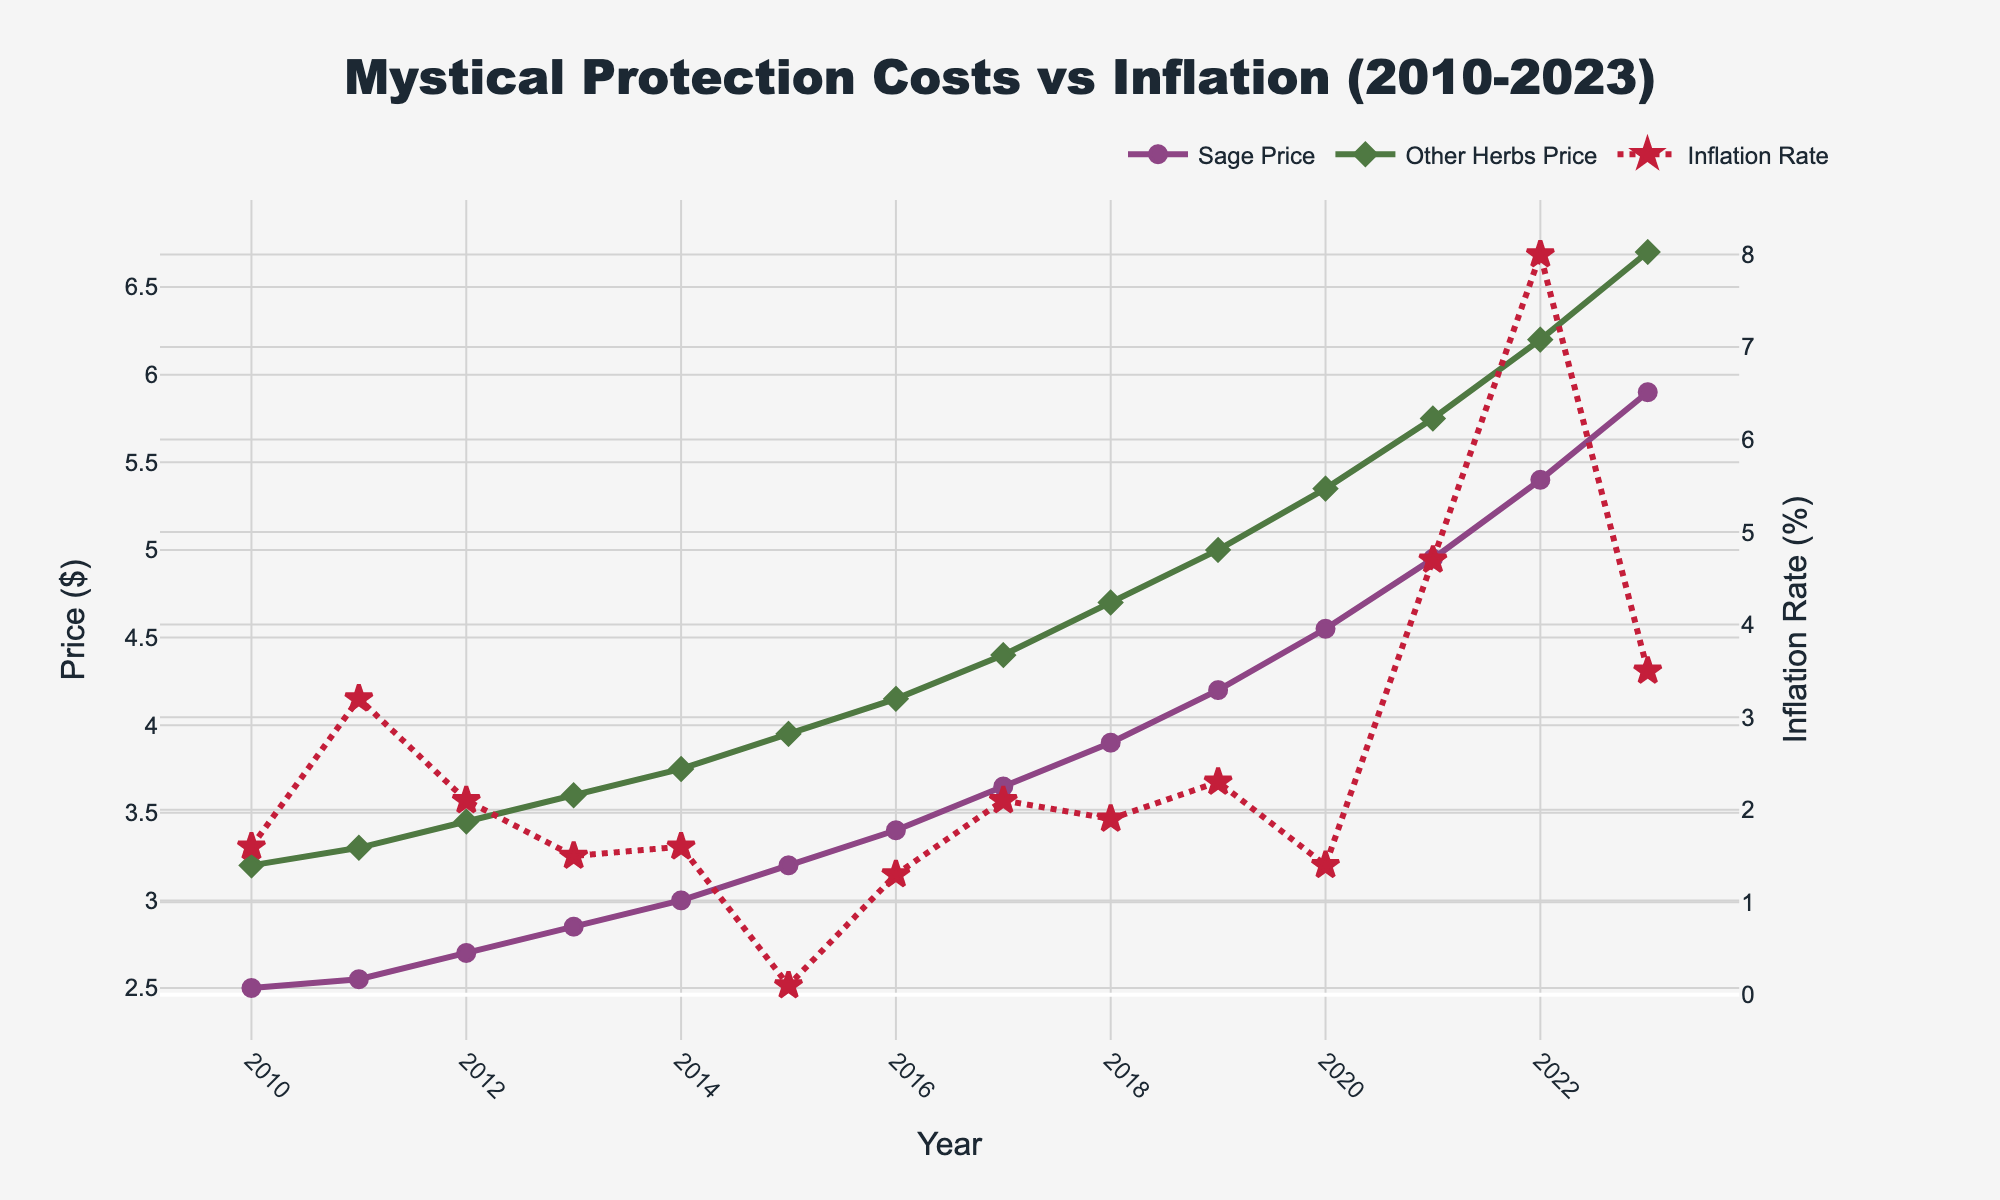What was the price difference between sage and other herbs in 2015? According to the figure, in 2015, the price of sage was $3.20, and the price of other herbs was $3.95. The difference is $3.95 - $3.20 = $0.75.
Answer: $0.75 In which year did the price of other herbs surpass $5.00? The figure shows that the price of other herbs first surpassed $5.00 in 2019, where it was exactly $5.00, and the next year, it was $5.35.
Answer: 2019 By how much did the inflation rate increase from 2020 to 2021? The figure indicates that the inflation rate in 2020 was 1.4%, and it increased to 4.7% in 2021. The increase is 4.7% - 1.4% = 3.3%.
Answer: 3.3% Which year had the highest inflation rate, and what was it? The figure reveals that 2022 had the highest inflation rate, which was 8.0%.
Answer: 2022, 8.0% How does the color and symbol of the line representing sage prices compare to that representing other herbs prices? The figure shows that the sage prices are represented by a purple line with circle markers, while the other herbs prices are represented by a green line with diamond markers.
Answer: Purple line with circles vs. green line with diamonds Compare the trends in prices of sage and other herbs between 2010 and 2013. From the figure, between 2010 and 2013, both sage and other herbs prices increased. Sage went from $2.50 to $2.85, while other herbs went from $3.20 to $3.60. Sage increased by $0.35 and other herbs by $0.40.
Answer: Both increased, sage by $0.35, other herbs by $0.40 What was the average inflation rate over the years when the sage price increased by $0.25 or more within a year? Sage price increased by $0.25 or more in 3 years: 2016-2017 (1.3%), 2017-2018 (2.1%), and 2019-2020 (1.4%). The average inflation rate for these years is (1.3 + 2.1 + 1.4) / 3 = 1.6%.
Answer: 1.6% Which had a more significant price increase from 2010 to 2023, sage or other herbs, and by how much? The figure shows that sage increased from $2.50 in 2010 to $5.90 in 2023, a $3.40 increase. Other herbs increased from $3.20 to $6.70, a $3.50 increase. Other herbs had a greater increase by $0.10.
Answer: Other herbs by $0.10 In what year did the inflation rate see its steepest increase, and what was the change? The figure shows the inflation rate's steepest increase occurred from 2021 to 2022, where it went from 4.7% to 8.0%, a change of 3.3%.
Answer: 2021 to 2022, 3.3% 